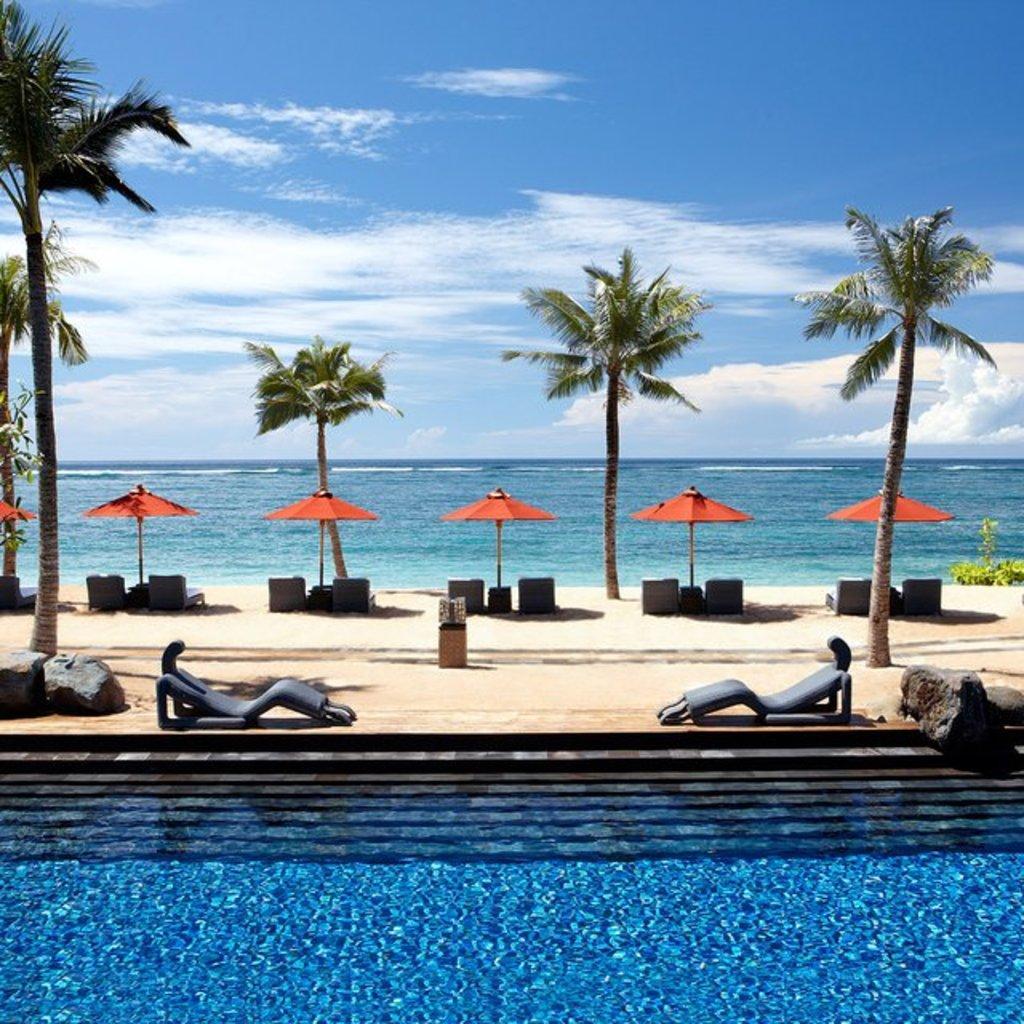In one or two sentences, can you explain what this image depicts? We can see water, chairs, trees, umbrellas, plants and rocks. In the background we can see water and sky with clouds. 